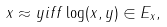<formula> <loc_0><loc_0><loc_500><loc_500>x \approx y i f f \log ( x , y ) \in E _ { x } ,</formula> 